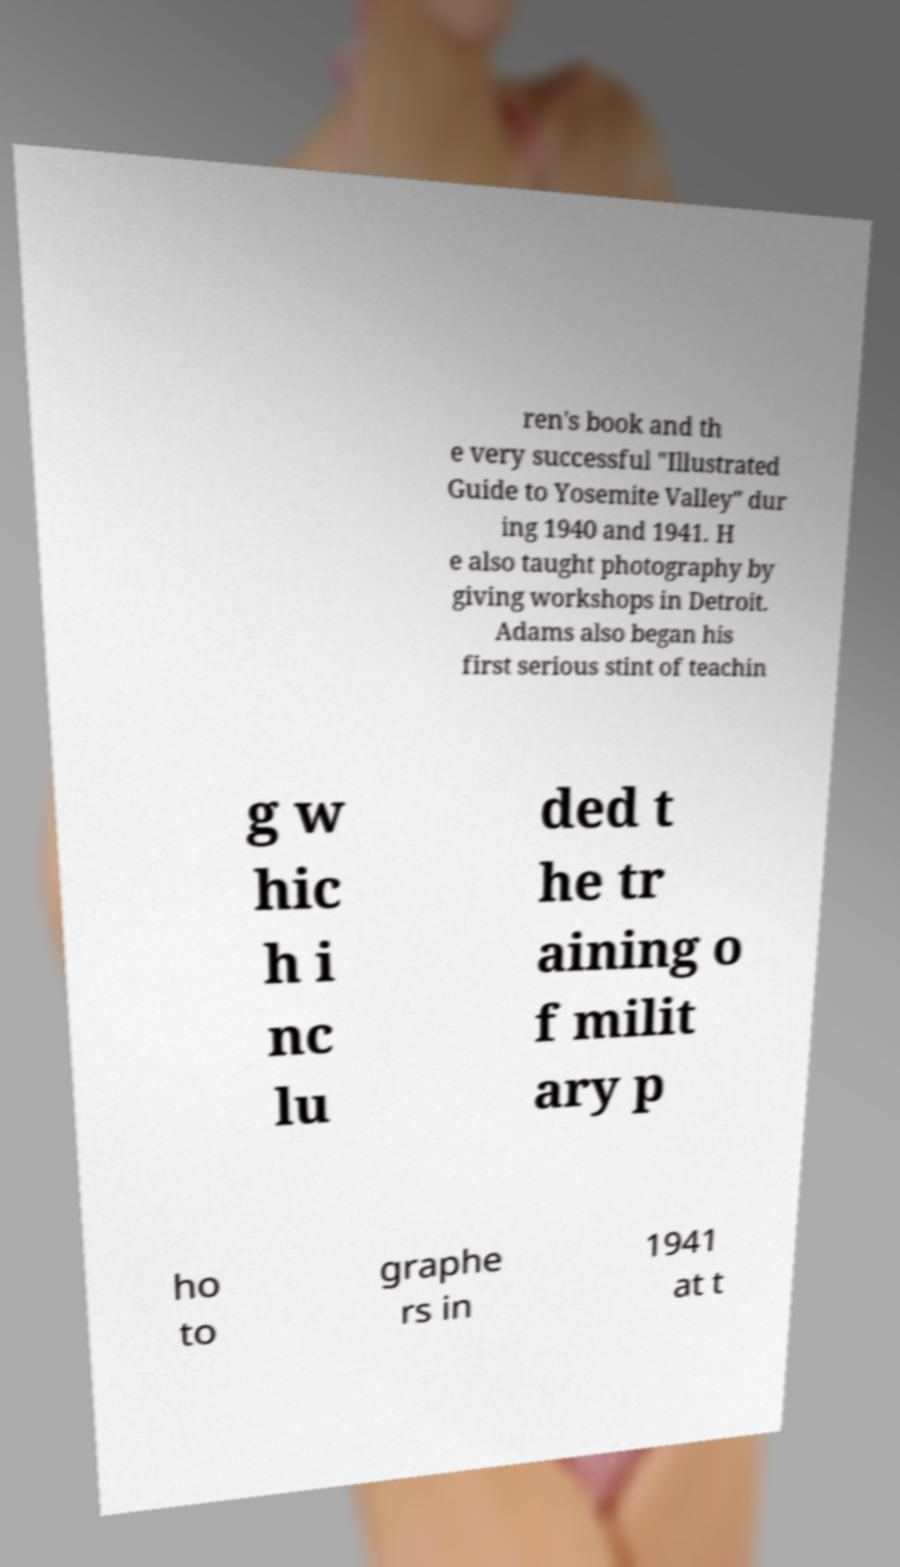There's text embedded in this image that I need extracted. Can you transcribe it verbatim? ren's book and th e very successful "Illustrated Guide to Yosemite Valley" dur ing 1940 and 1941. H e also taught photography by giving workshops in Detroit. Adams also began his first serious stint of teachin g w hic h i nc lu ded t he tr aining o f milit ary p ho to graphe rs in 1941 at t 